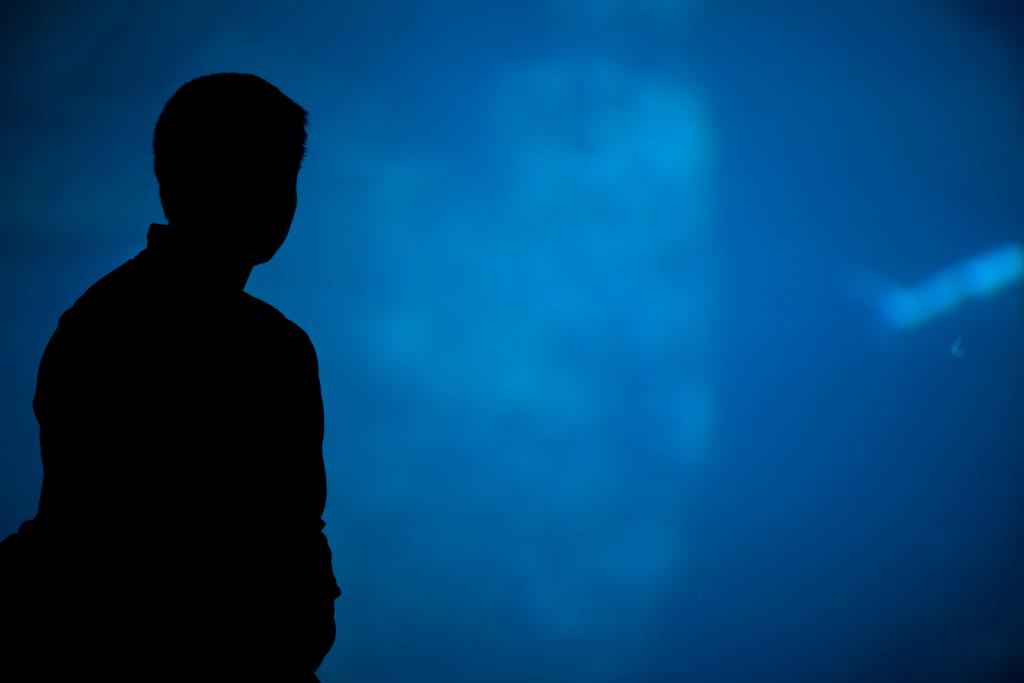Who is present on the left side of the image? There is a person on the left side of the image. What color is the background of the image? The background of the image is blue. What type of legal advice is the lawyer providing in the image? There is no lawyer present in the image, so it is not possible to determine what legal advice might be provided. 